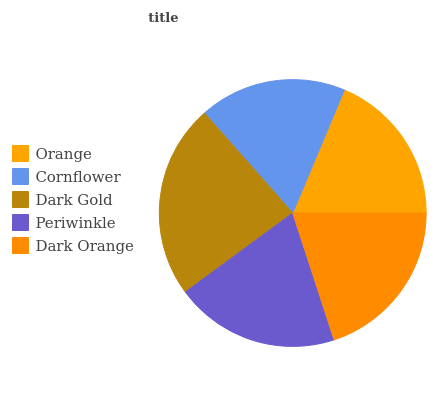Is Cornflower the minimum?
Answer yes or no. Yes. Is Dark Gold the maximum?
Answer yes or no. Yes. Is Dark Gold the minimum?
Answer yes or no. No. Is Cornflower the maximum?
Answer yes or no. No. Is Dark Gold greater than Cornflower?
Answer yes or no. Yes. Is Cornflower less than Dark Gold?
Answer yes or no. Yes. Is Cornflower greater than Dark Gold?
Answer yes or no. No. Is Dark Gold less than Cornflower?
Answer yes or no. No. Is Periwinkle the high median?
Answer yes or no. Yes. Is Periwinkle the low median?
Answer yes or no. Yes. Is Dark Gold the high median?
Answer yes or no. No. Is Dark Orange the low median?
Answer yes or no. No. 